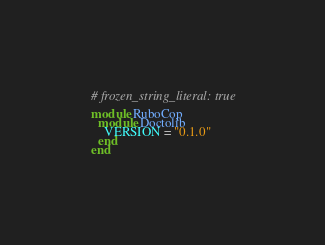<code> <loc_0><loc_0><loc_500><loc_500><_Ruby_># frozen_string_literal: true

module RuboCop
  module Doctolib
    VERSION = "0.1.0"
  end
end
</code> 